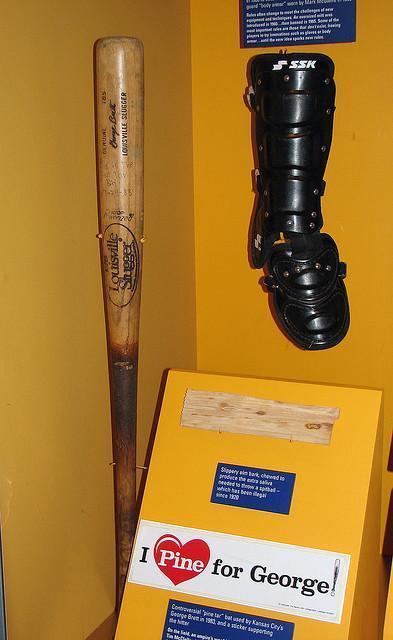How many boats are there?
Give a very brief answer. 0. 